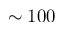<formula> <loc_0><loc_0><loc_500><loc_500>\sim 1 0 0</formula> 